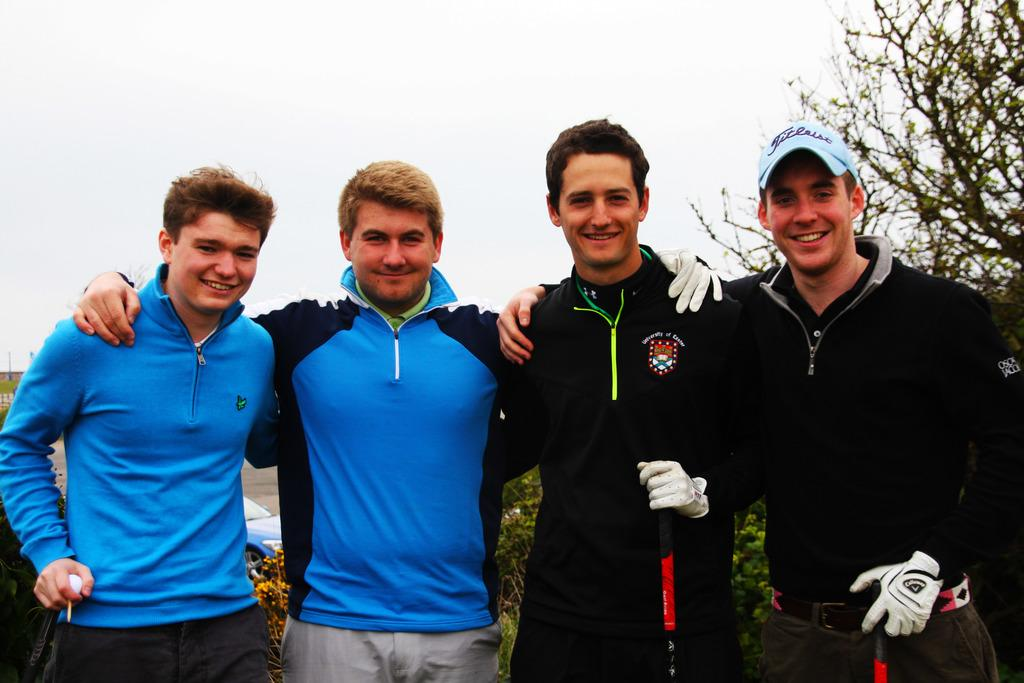How many people are in the image? There are four persons in the image. What are the persons doing in the image? The persons are standing and smiling. What are the persons holding in the image? The persons are holding sticks. What can be seen in the background of the image? There is a car, plants, a tree, and the sky visible in the background of the image. What type of birthday cake is being served in the image? There is no birthday cake present in the image. Can you tell me how many tigers are visible in the image? There are no tigers visible in the image. 